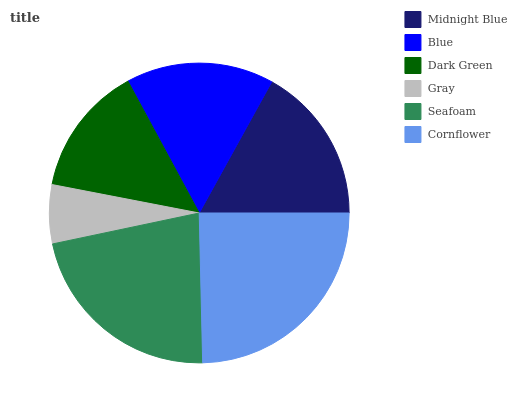Is Gray the minimum?
Answer yes or no. Yes. Is Cornflower the maximum?
Answer yes or no. Yes. Is Blue the minimum?
Answer yes or no. No. Is Blue the maximum?
Answer yes or no. No. Is Midnight Blue greater than Blue?
Answer yes or no. Yes. Is Blue less than Midnight Blue?
Answer yes or no. Yes. Is Blue greater than Midnight Blue?
Answer yes or no. No. Is Midnight Blue less than Blue?
Answer yes or no. No. Is Midnight Blue the high median?
Answer yes or no. Yes. Is Blue the low median?
Answer yes or no. Yes. Is Cornflower the high median?
Answer yes or no. No. Is Seafoam the low median?
Answer yes or no. No. 